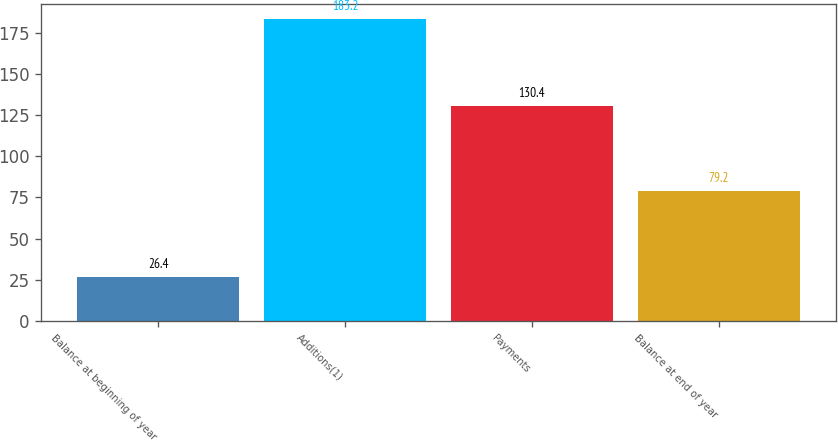<chart> <loc_0><loc_0><loc_500><loc_500><bar_chart><fcel>Balance at beginning of year<fcel>Additions(1)<fcel>Payments<fcel>Balance at end of year<nl><fcel>26.4<fcel>183.2<fcel>130.4<fcel>79.2<nl></chart> 